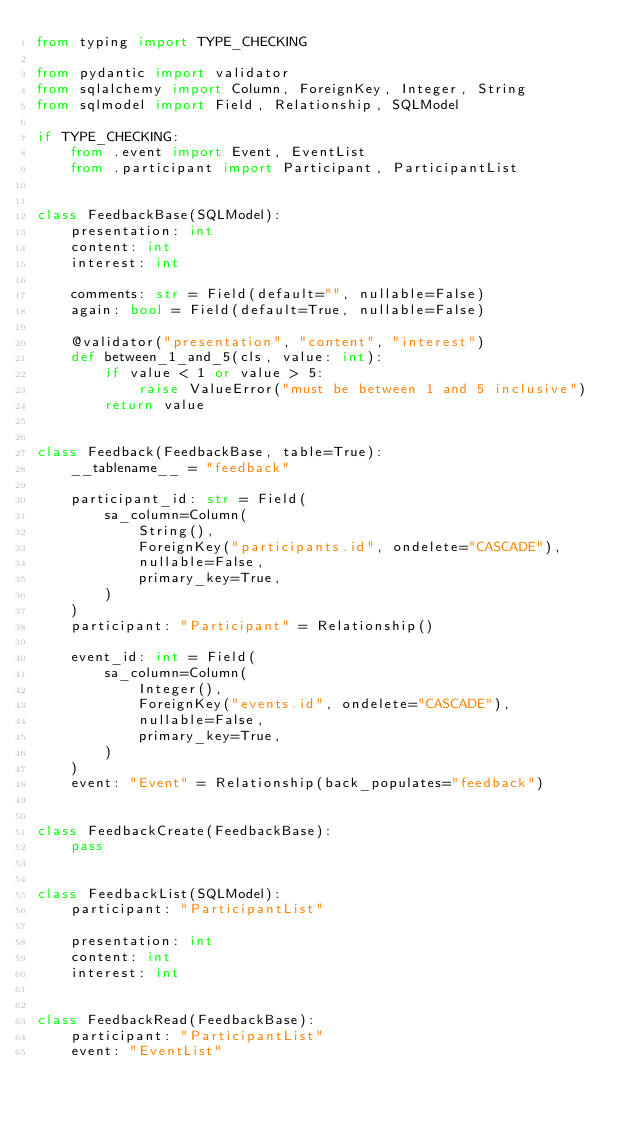<code> <loc_0><loc_0><loc_500><loc_500><_Python_>from typing import TYPE_CHECKING

from pydantic import validator
from sqlalchemy import Column, ForeignKey, Integer, String
from sqlmodel import Field, Relationship, SQLModel

if TYPE_CHECKING:
    from .event import Event, EventList
    from .participant import Participant, ParticipantList


class FeedbackBase(SQLModel):
    presentation: int
    content: int
    interest: int

    comments: str = Field(default="", nullable=False)
    again: bool = Field(default=True, nullable=False)

    @validator("presentation", "content", "interest")
    def between_1_and_5(cls, value: int):
        if value < 1 or value > 5:
            raise ValueError("must be between 1 and 5 inclusive")
        return value


class Feedback(FeedbackBase, table=True):
    __tablename__ = "feedback"

    participant_id: str = Field(
        sa_column=Column(
            String(),
            ForeignKey("participants.id", ondelete="CASCADE"),
            nullable=False,
            primary_key=True,
        )
    )
    participant: "Participant" = Relationship()

    event_id: int = Field(
        sa_column=Column(
            Integer(),
            ForeignKey("events.id", ondelete="CASCADE"),
            nullable=False,
            primary_key=True,
        )
    )
    event: "Event" = Relationship(back_populates="feedback")


class FeedbackCreate(FeedbackBase):
    pass


class FeedbackList(SQLModel):
    participant: "ParticipantList"

    presentation: int
    content: int
    interest: int


class FeedbackRead(FeedbackBase):
    participant: "ParticipantList"
    event: "EventList"
</code> 